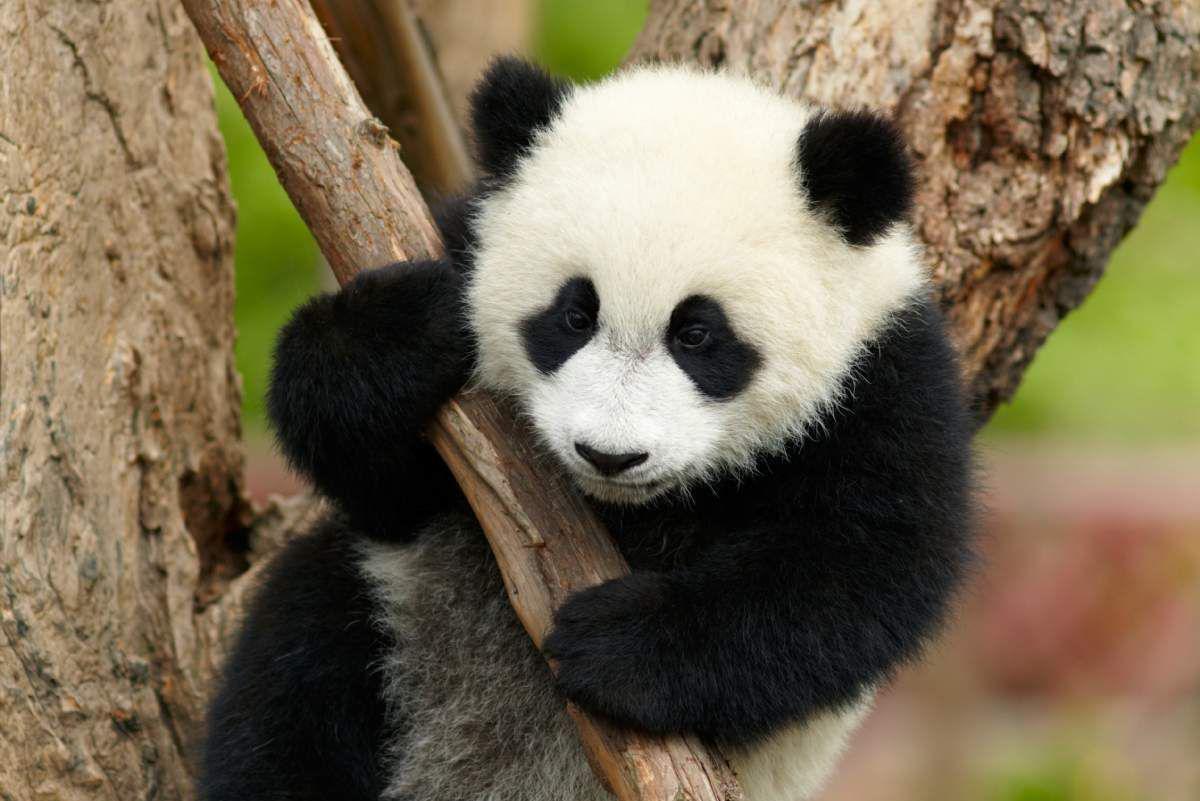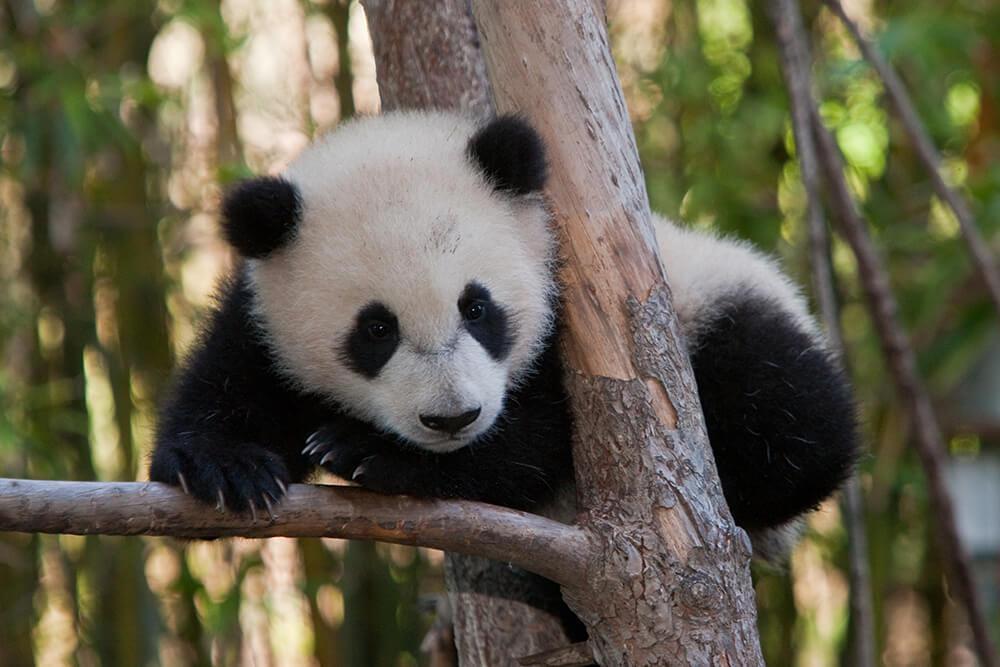The first image is the image on the left, the second image is the image on the right. For the images displayed, is the sentence "There is exactly one panda with all feet on the ground in one of the images" factually correct? Answer yes or no. No. The first image is the image on the left, the second image is the image on the right. Considering the images on both sides, is "At least one of the pandas is holding onto a tree branch." valid? Answer yes or no. Yes. The first image is the image on the left, the second image is the image on the right. Given the left and right images, does the statement "An image shows a panda with paws over a horizontal  tree limb." hold true? Answer yes or no. Yes. The first image is the image on the left, the second image is the image on the right. Given the left and right images, does the statement "The panda in the right image has paws on a branch." hold true? Answer yes or no. Yes. 